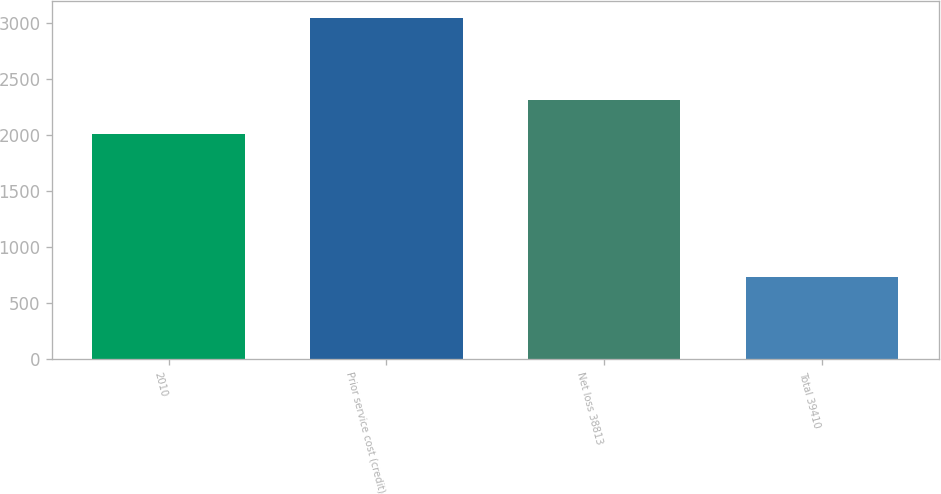Convert chart. <chart><loc_0><loc_0><loc_500><loc_500><bar_chart><fcel>2010<fcel>Prior service cost (credit)<fcel>Net loss 38813<fcel>Total 39410<nl><fcel>2010<fcel>3044<fcel>2313<fcel>731<nl></chart> 